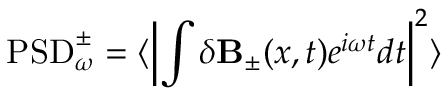<formula> <loc_0><loc_0><loc_500><loc_500>P S D _ { \omega } ^ { \pm } = \langle \left | \int \delta { B } _ { \pm } ( x , t ) e ^ { i \omega t } d t \right | ^ { 2 } \rangle</formula> 